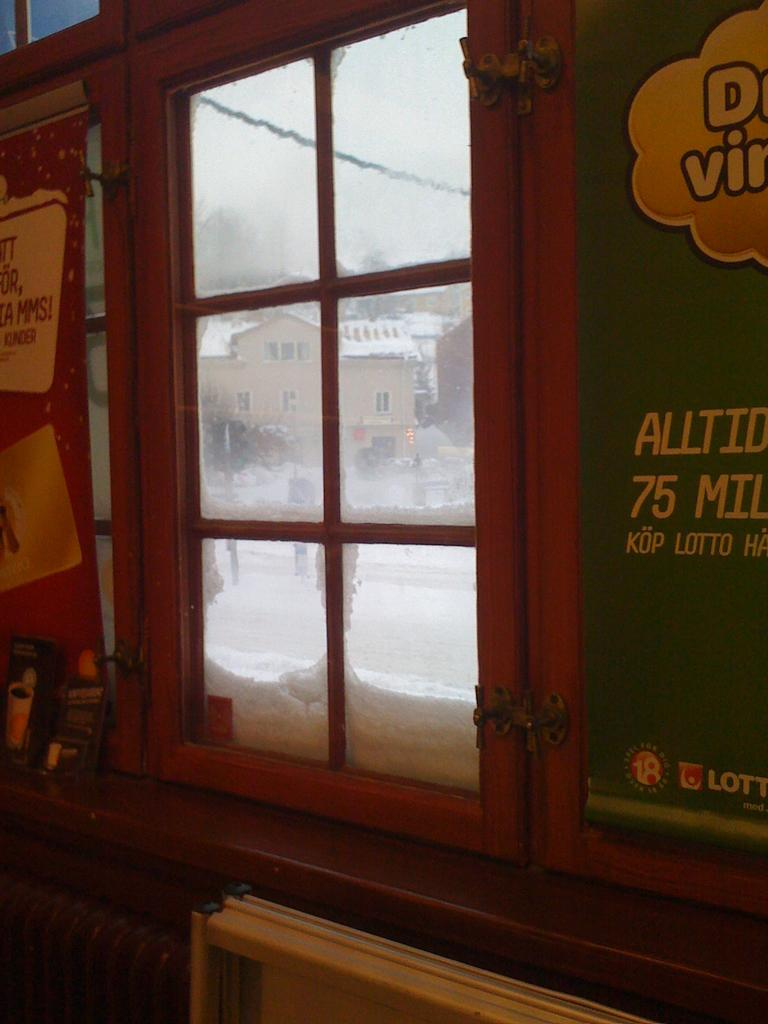What can be seen through the window in the picture? Buildings, trees, and the sky are visible from the window in the picture. What type of writing is present on the boards in the picture? The boards in the picture have writing on them. What other objects can be seen from the window in the picture? There are other objects visible from the window, but their specific details are not mentioned in the provided facts. Who is the manager of the trip visible from the window in the picture? There is no trip visible from the window in the picture, and therefore no manager associated with it. 